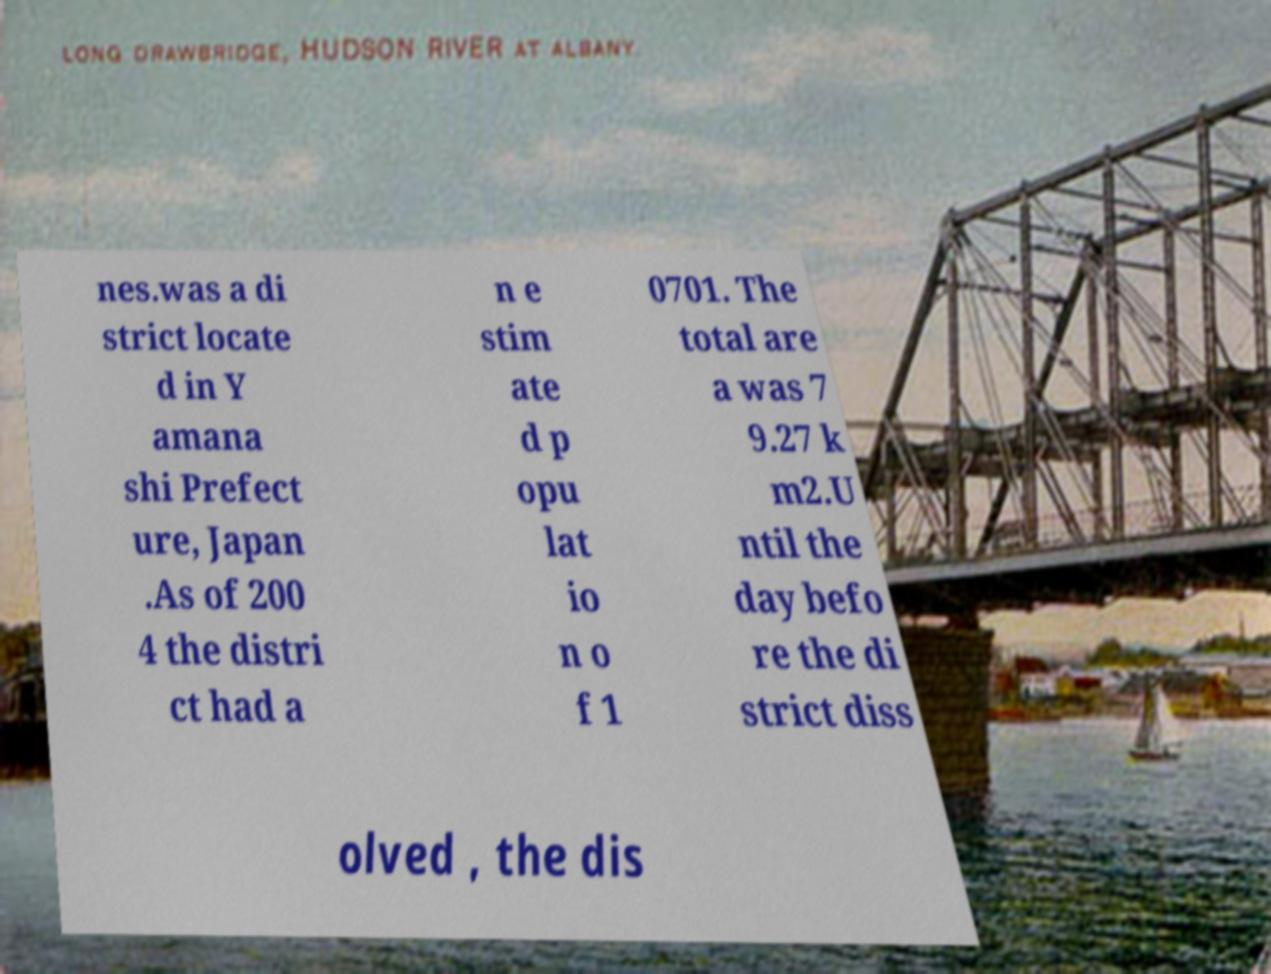Can you accurately transcribe the text from the provided image for me? nes.was a di strict locate d in Y amana shi Prefect ure, Japan .As of 200 4 the distri ct had a n e stim ate d p opu lat io n o f 1 0701. The total are a was 7 9.27 k m2.U ntil the day befo re the di strict diss olved , the dis 